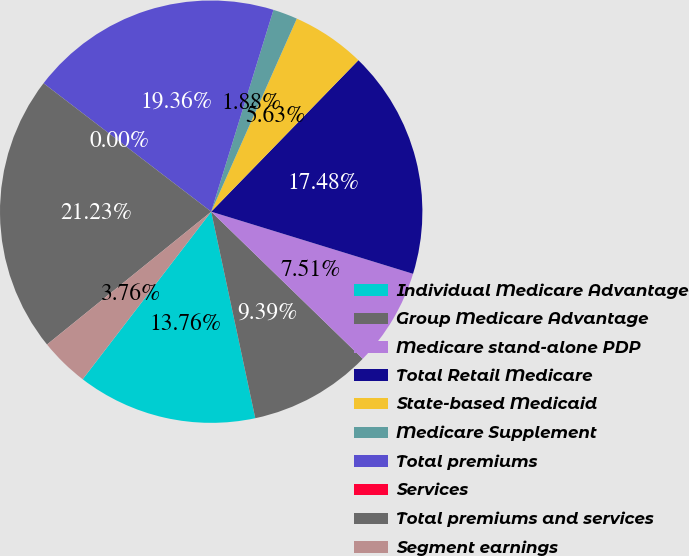Convert chart. <chart><loc_0><loc_0><loc_500><loc_500><pie_chart><fcel>Individual Medicare Advantage<fcel>Group Medicare Advantage<fcel>Medicare stand-alone PDP<fcel>Total Retail Medicare<fcel>State-based Medicaid<fcel>Medicare Supplement<fcel>Total premiums<fcel>Services<fcel>Total premiums and services<fcel>Segment earnings<nl><fcel>13.76%<fcel>9.39%<fcel>7.51%<fcel>17.48%<fcel>5.63%<fcel>1.88%<fcel>19.36%<fcel>0.0%<fcel>21.23%<fcel>3.76%<nl></chart> 